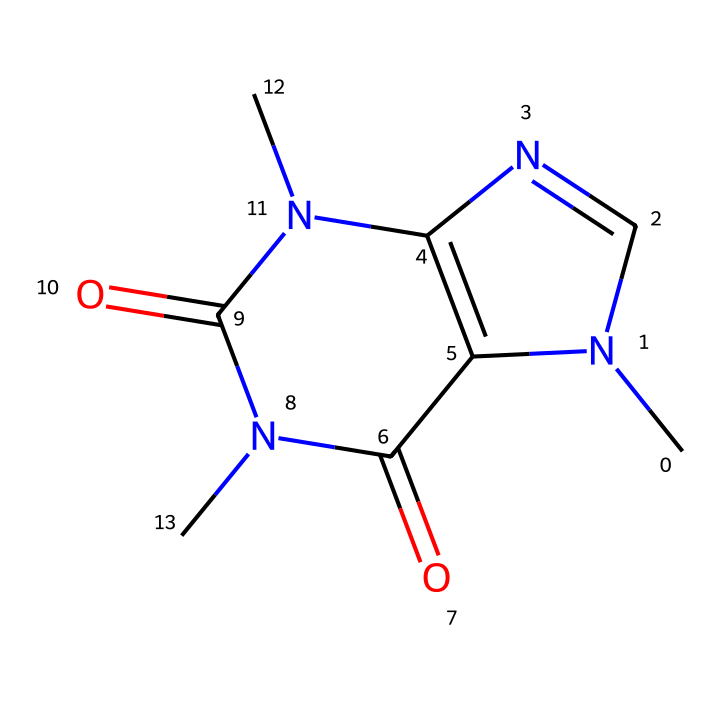How many nitrogen atoms are present in caffeine? The provided SMILES shows the structure of caffeine, which includes multiple atoms. By analyzing the structure, you can count the nitrogen (N) atoms present. There are three nitrogen atoms in the structure.
Answer: three What is the molecular formula of caffeine? To obtain the molecular formula, you must count the number of each type of atom in the SMILES representation. From the structure, there are 8 carbon (C) atoms, 10 hydrogen (H) atoms, and 4 nitrogen (N) atoms. Thus, the molecular formula is C8H10N4O2.
Answer: C8H10N4O2 What is the functional group present in caffeine that categorizes it as an imide? In analysing the structure, you're looking for the specific feature that signifies an imide. The presence of the carbonyl group (C=O) adjacent to a nitrogen atom (N) indicates its classification as an imide.
Answer: carbonyl Which part of caffeine contributes to its stimulant properties? Examining the structure reveals that the nitrogen atoms are key in influencing the stimulant properties, specifically through their role in forming hydrogen bonds and interactions with adenosine receptors in the brain.
Answer: nitrogen atoms How many carbonyl groups are present in caffeine? By closely examining the SMILES representation for C=O bonds, you can identify the carbonyl groups. There are two carbonyl groups in the caffeine structure.
Answer: two What type of bonding occurs between the nitrogen and carbon atoms in caffeine? Analyzing the structure reveals that the connections between nitrogen and carbon atoms are primarily through covalent bonding, as they share electron pairs.
Answer: covalent What is the significance of the imide structure in caffeine for its biological activity? The imide structure enhances solubility and impacts metabolic pathways crucial for caffeine's interaction with biological systems, primarily as a CNS stimulant.
Answer: solubility and metabolism 